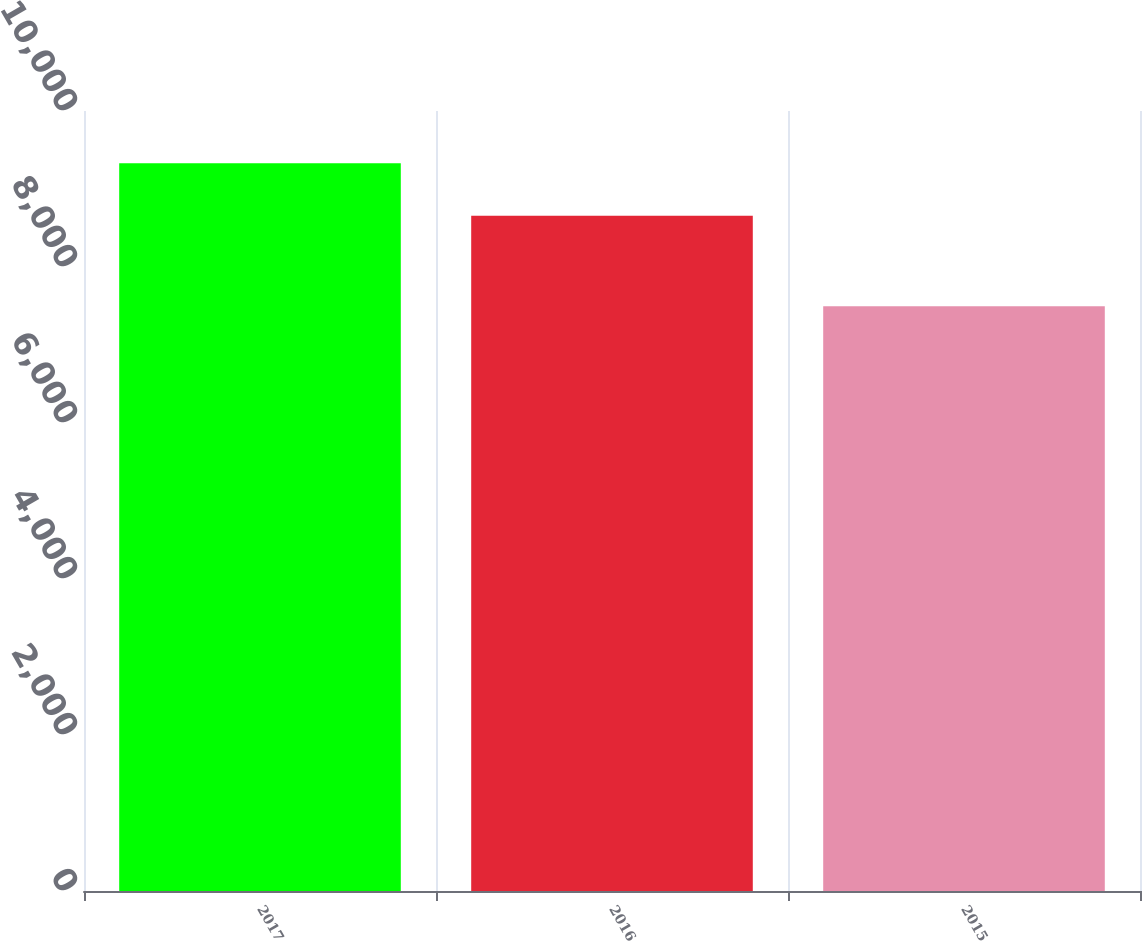Convert chart. <chart><loc_0><loc_0><loc_500><loc_500><bar_chart><fcel>2017<fcel>2016<fcel>2015<nl><fcel>9330<fcel>8657<fcel>7496<nl></chart> 